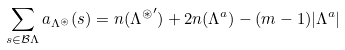<formula> <loc_0><loc_0><loc_500><loc_500>\sum _ { s \in \mathcal { B } \Lambda } a _ { \Lambda ^ { \circledast } } ( s ) = n ( { \Lambda ^ { \circledast } } ^ { \prime } ) + 2 n ( \Lambda ^ { a } ) - ( m - 1 ) | \Lambda ^ { a } |</formula> 